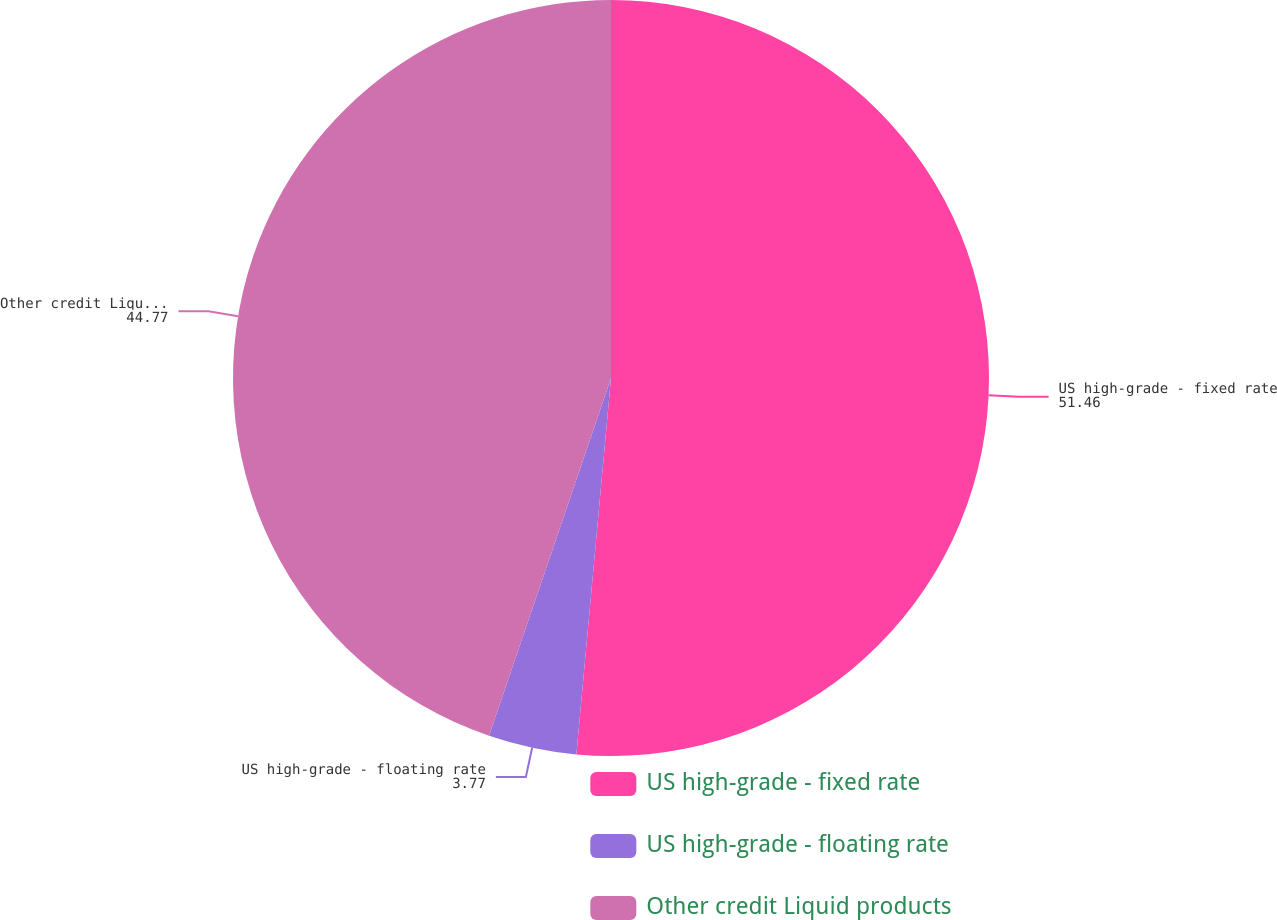Convert chart to OTSL. <chart><loc_0><loc_0><loc_500><loc_500><pie_chart><fcel>US high-grade - fixed rate<fcel>US high-grade - floating rate<fcel>Other credit Liquid products<nl><fcel>51.46%<fcel>3.77%<fcel>44.77%<nl></chart> 